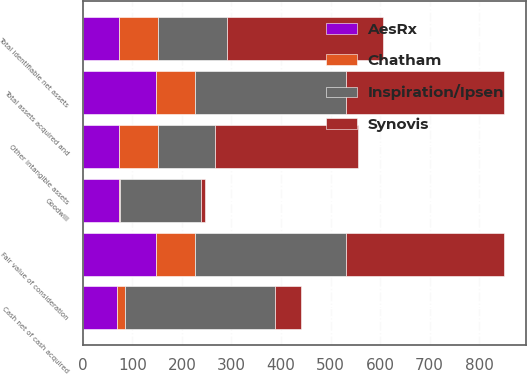<chart> <loc_0><loc_0><loc_500><loc_500><stacked_bar_chart><ecel><fcel>Cash net of cash acquired<fcel>Fair value of consideration<fcel>Other intangible assets<fcel>Total identifiable net assets<fcel>Goodwill<fcel>Total assets acquired and<nl><fcel>AesRx<fcel>70<fcel>147<fcel>74<fcel>74<fcel>73<fcel>147<nl><fcel>Chatham<fcel>15<fcel>80<fcel>78<fcel>78<fcel>2<fcel>80<nl><fcel>Synovis<fcel>51<fcel>320<fcel>288<fcel>313<fcel>7<fcel>320<nl><fcel>Inspiration/Ipsen<fcel>304<fcel>304<fcel>115<fcel>140<fcel>164<fcel>304<nl></chart> 